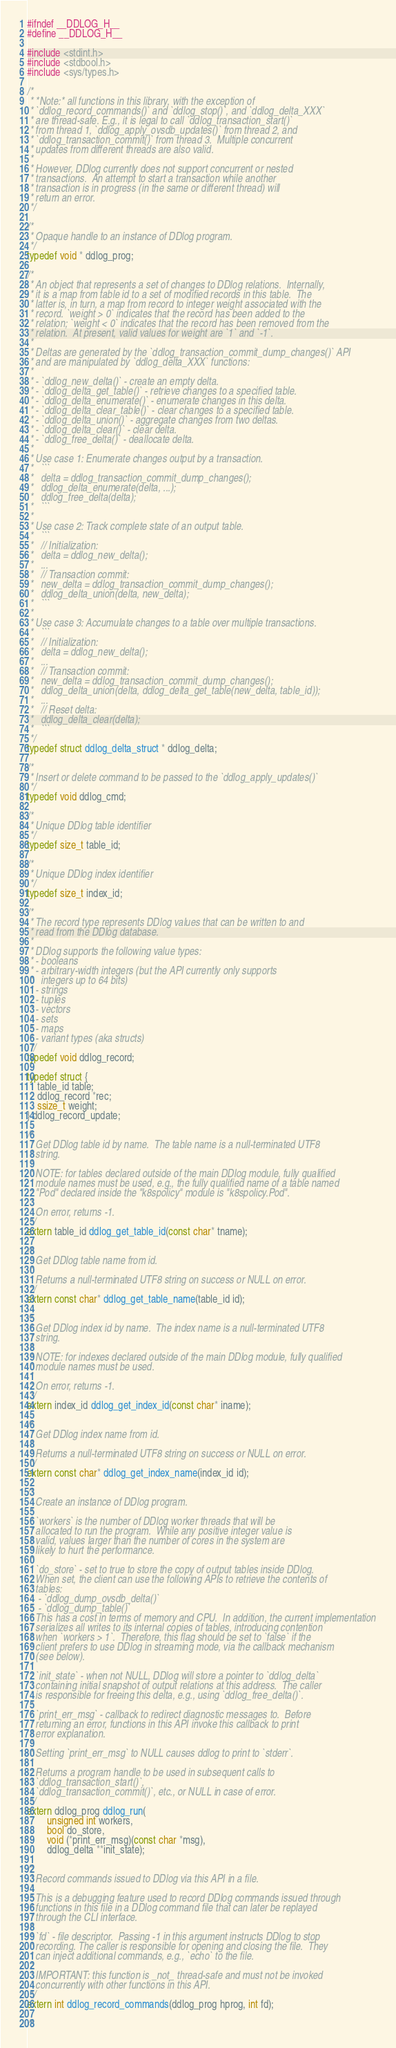<code> <loc_0><loc_0><loc_500><loc_500><_C_>#ifndef __DDLOG_H__
#define __DDLOG_H__

#include <stdint.h>
#include <stdbool.h>
#include <sys/types.h>

/*
 * *Note:* all functions in this library, with the exception of
 * `ddlog_record_commands()` and `ddlog_stop()`, and `ddlog_delta_XXX`
 * are thread-safe. E.g., it is legal to call `ddlog_transaction_start()`
 * from thread 1, `ddlog_apply_ovsdb_updates()` from thread 2, and
 * `ddlog_transaction_commit()` from thread 3.  Multiple concurrent
 * updates from different threads are also valid.
 *
 * However, DDlog currently does not support concurrent or nested
 * transactions.  An attempt to start a transaction while another
 * transaction is in progress (in the same or different thread) will
 * return an error.
 */

/*
 * Opaque handle to an instance of DDlog program.
 */
typedef void * ddlog_prog;

/*
 * An object that represents a set of changes to DDlog relations.  Internally,
 * it is a map from table id to a set of modified records in this table.  The
 * latter is, in turn, a map from record to integer weight associated with the
 * record. `weight > 0` indicates that the record has been added to the
 * relation; `weight < 0` indicates that the record has been removed from the
 * relation.  At present, valid values for weight are `1` and `-1`.
 *
 * Deltas are generated by the `ddlog_transaction_commit_dump_changes()` API
 * and are manipulated by `ddlog_delta_XXX` functions:
 *
 * - `ddlog_new_delta()` - create an empty delta.
 * - `ddlog_delta_get_table()` - retrieve changes to a specified table.
 * - `ddlog_delta_enumerate()` - enumerate changes in this delta.
 * - `ddlog_delta_clear_table()` - clear changes to a specified table.
 * - `ddlog_delta_union()` - aggregate changes from two deltas.
 * - `ddlog_delta_clear()` - clear delta.
 * - `ddlog_free_delta()` - deallocate delta.
 *
 * Use case 1: Enumerate changes output by a transaction.
 *   ```
 *   delta = ddlog_transaction_commit_dump_changes();
 *   ddlog_delta_enumerate(delta, ...);
 *   ddlog_free_delta(delta);
 *   ```
 *
 * Use case 2: Track complete state of an output table.
 *   ```
 *   // Initialization:
 *   delta = ddlog_new_delta();
 *   ...
 *   // Transaction commit:
 *   new_delta = ddlog_transaction_commit_dump_changes();
 *   ddlog_delta_union(delta, new_delta);
 *   ```
 *
 * Use case 3: Accumulate changes to a table over multiple transactions.
 *   ```
 *   // Initialization:
 *   delta = ddlog_new_delta();
 *   ...
 *   // Transaction commit:
 *   new_delta = ddlog_transaction_commit_dump_changes();
 *   ddlog_delta_union(delta, ddlog_delta_get_table(new_delta, table_id));
 *   ...
 *   // Reset delta:
 *   ddlog_delta_clear(delta);
 *   ```
 */
typedef struct ddlog_delta_struct * ddlog_delta;

/*
 * Insert or delete command to be passed to the `ddlog_apply_updates()`
 */
typedef void ddlog_cmd;

/*
 * Unique DDlog table identifier
 */
typedef size_t table_id;

/*
 * Unique DDlog index identifier
 */
typedef size_t index_id;

/*
 * The record type represents DDlog values that can be written to and
 * read from the DDlog database.
 *
 * DDlog supports the following value types:
 * - booleans
 * - arbitrary-width integers (but the API currently only supports
 *   integers up to 64 bits)
 * - strings
 * - tuples
 * - vectors
 * - sets
 * - maps
 * - variant types (aka structs)
 */
typedef void ddlog_record;

typedef struct {
    table_id table;
    ddlog_record *rec;
    ssize_t weight;
} ddlog_record_update;

/*
 * Get DDlog table id by name.  The table name is a null-terminated UTF8
 * string.
 *
 * NOTE: for tables declared outside of the main DDlog module, fully qualified
 * module names must be used, e.g., the fully qualified name of a table named
 * "Pod" declared inside the "k8spolicy" module is "k8spolicy.Pod".
 *
 * On error, returns -1.
 */
extern table_id ddlog_get_table_id(const char* tname);

/*
 * Get DDlog table name from id.
 *
 * Returns a null-terminated UTF8 string on success or NULL on error.
 */
extern const char* ddlog_get_table_name(table_id id);

/*
 * Get DDlog index id by name.  The index name is a null-terminated UTF8
 * string.
 *
 * NOTE: for indexes declared outside of the main DDlog module, fully qualified
 * module names must be used.
 *
 * On error, returns -1.
 */
extern index_id ddlog_get_index_id(const char* iname);

/*
 * Get DDlog index name from id.
 *
 * Returns a null-terminated UTF8 string on success or NULL on error.
 */
extern const char* ddlog_get_index_name(index_id id);

/*
 * Create an instance of DDlog program.
 *
 * `workers` is the number of DDlog worker threads that will be
 * allocated to run the program.  While any positive integer value is
 * valid, values larger than the number of cores in the system are
 * likely to hurt the performance.
 *
 * `do_store` - set to true to store the copy of output tables inside DDlog.
 * When set, the client can use the following APIs to retrieve the contents of
 * tables:
 *	- `ddlog_dump_ovsdb_delta()`
 *	- `ddlog_dump_table()`
 * This has a cost in terms of memory and CPU.  In addition, the current implementation
 * serializes all writes to its internal copies of tables, introducing contention
 * when `workers > 1`.  Therefore, this flag should be set to `false` if the
 * client prefers to use DDlog in streaming mode, via the callback mechanism
 * (see below).
 *
 * `init_state` - when not NULL, DDlog will store a pointer to `ddlog_delta`
 * containing initial snapshot of output relations at this address.  The caller
 * is responsible for freeing this delta, e.g., using `ddlog_free_delta()`.
 *
 * `print_err_msg` - callback to redirect diagnostic messages to.  Before
 * returning an error, functions in this API invoke this callback to print
 * error explanation.
 *
 * Setting `print_err_msg` to NULL causes ddlog to print to `stderr`.
 *
 * Returns a program handle to be used in subsequent calls to
 * `ddlog_transaction_start()`,
 * `ddlog_transaction_commit()`, etc., or NULL in case of error.
 */
extern ddlog_prog ddlog_run(
        unsigned int workers,
        bool do_store,
        void (*print_err_msg)(const char *msg),
        ddlog_delta **init_state);

/*
 * Record commands issued to DDlog via this API in a file.
 *
 * This is a debugging feature used to record DDlog commands issued through
 * functions in this file in a DDlog command file that can later be replayed
 * through the CLI interface.
 *
 * `fd` - file descriptor.  Passing -1 in this argument instructs DDlog to stop
 * recording. The caller is responsible for opening and closing the file.  They
 * can inject additional commands, e.g., `echo` to the file.
 *
 * IMPORTANT: this function is _not_ thread-safe and must not be invoked
 * concurrently with other functions in this API.
 */
extern int ddlog_record_commands(ddlog_prog hprog, int fd);

/*</code> 